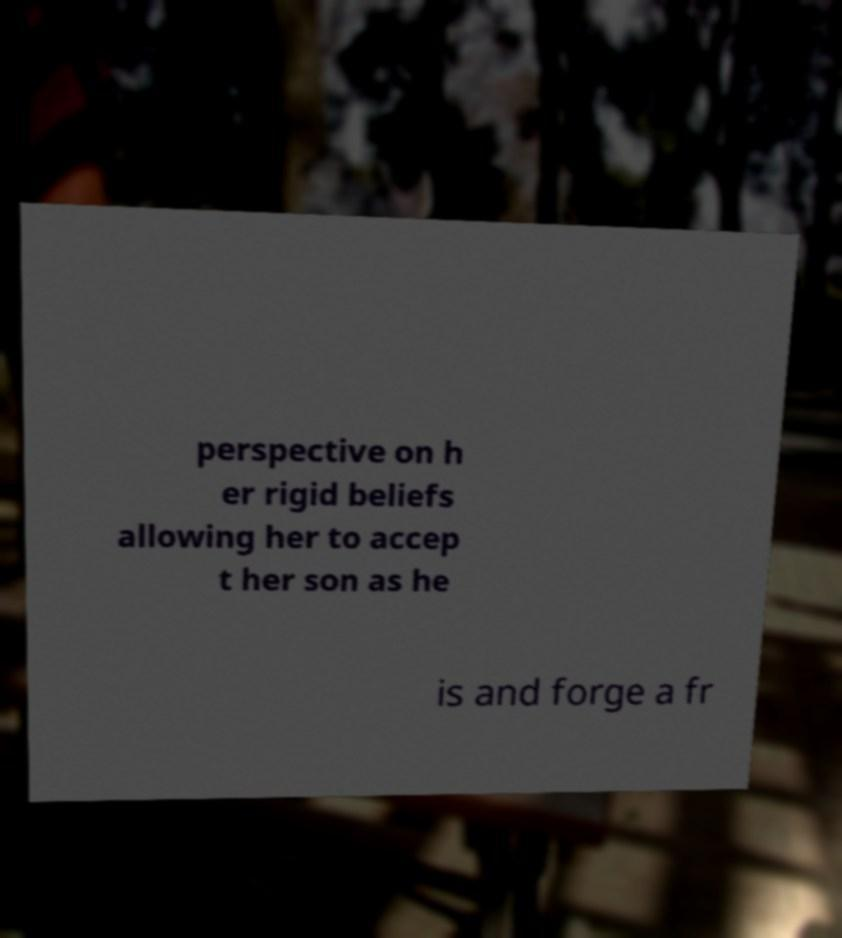Could you extract and type out the text from this image? perspective on h er rigid beliefs allowing her to accep t her son as he is and forge a fr 